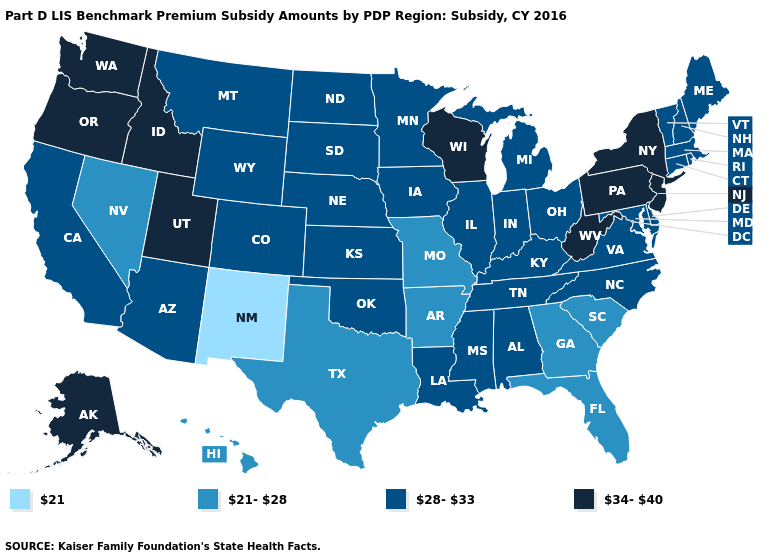Which states have the highest value in the USA?
Give a very brief answer. Alaska, Idaho, New Jersey, New York, Oregon, Pennsylvania, Utah, Washington, West Virginia, Wisconsin. Does the first symbol in the legend represent the smallest category?
Answer briefly. Yes. Does Georgia have a higher value than New Mexico?
Give a very brief answer. Yes. What is the highest value in the USA?
Answer briefly. 34-40. Name the states that have a value in the range 28-33?
Be succinct. Alabama, Arizona, California, Colorado, Connecticut, Delaware, Illinois, Indiana, Iowa, Kansas, Kentucky, Louisiana, Maine, Maryland, Massachusetts, Michigan, Minnesota, Mississippi, Montana, Nebraska, New Hampshire, North Carolina, North Dakota, Ohio, Oklahoma, Rhode Island, South Dakota, Tennessee, Vermont, Virginia, Wyoming. What is the lowest value in states that border Idaho?
Give a very brief answer. 21-28. Name the states that have a value in the range 21-28?
Short answer required. Arkansas, Florida, Georgia, Hawaii, Missouri, Nevada, South Carolina, Texas. What is the value of New Mexico?
Answer briefly. 21. Is the legend a continuous bar?
Concise answer only. No. Does the first symbol in the legend represent the smallest category?
Write a very short answer. Yes. How many symbols are there in the legend?
Quick response, please. 4. Which states have the lowest value in the MidWest?
Keep it brief. Missouri. Does the map have missing data?
Short answer required. No. Among the states that border Oklahoma , does New Mexico have the lowest value?
Give a very brief answer. Yes. What is the lowest value in states that border Virginia?
Keep it brief. 28-33. 